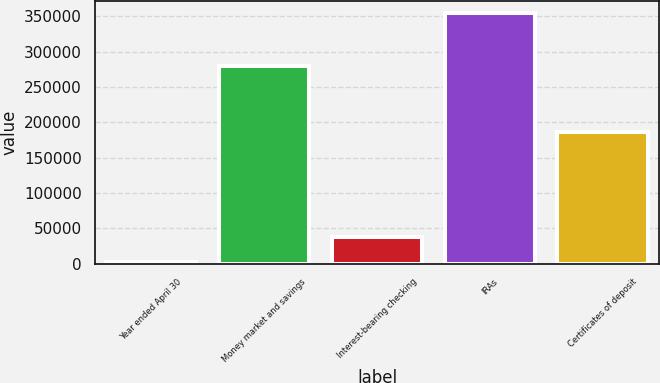<chart> <loc_0><loc_0><loc_500><loc_500><bar_chart><fcel>Year ended April 30<fcel>Money market and savings<fcel>Interest-bearing checking<fcel>IRAs<fcel>Certificates of deposit<nl><fcel>2011<fcel>279162<fcel>37200.1<fcel>353902<fcel>186742<nl></chart> 